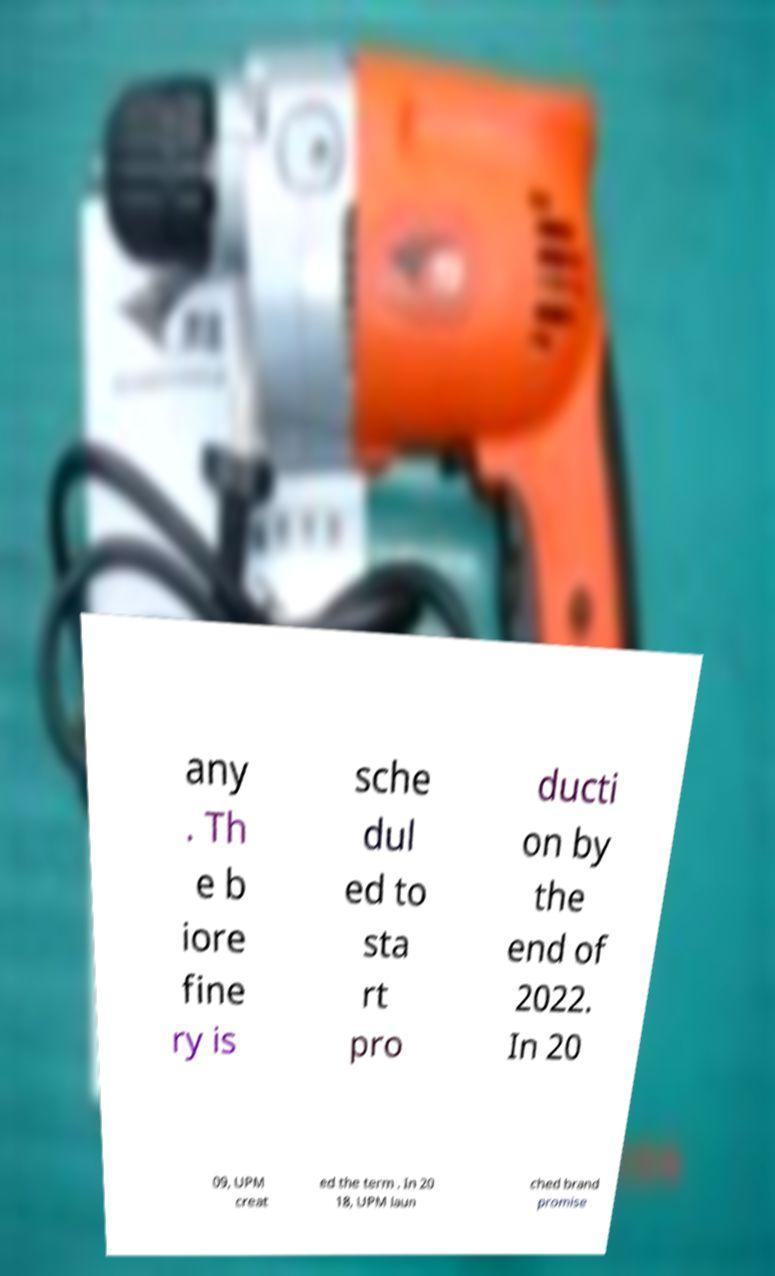What messages or text are displayed in this image? I need them in a readable, typed format. any . Th e b iore fine ry is sche dul ed to sta rt pro ducti on by the end of 2022. In 20 09, UPM creat ed the term . In 20 18, UPM laun ched brand promise 